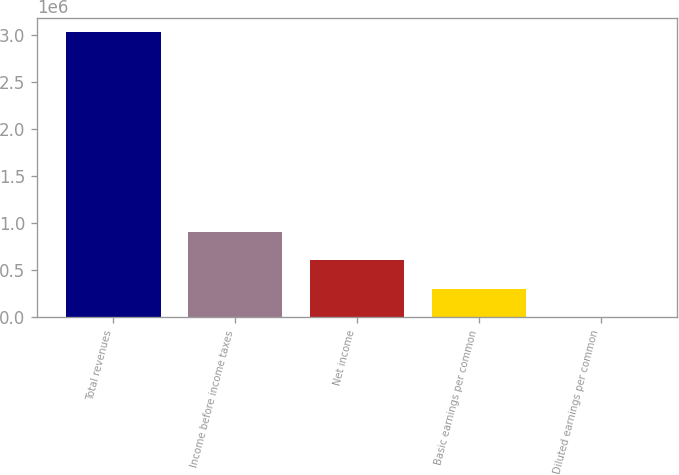Convert chart to OTSL. <chart><loc_0><loc_0><loc_500><loc_500><bar_chart><fcel>Total revenues<fcel>Income before income taxes<fcel>Net income<fcel>Basic earnings per common<fcel>Diluted earnings per common<nl><fcel>3.02996e+06<fcel>908988<fcel>605992<fcel>302996<fcel>0.43<nl></chart> 